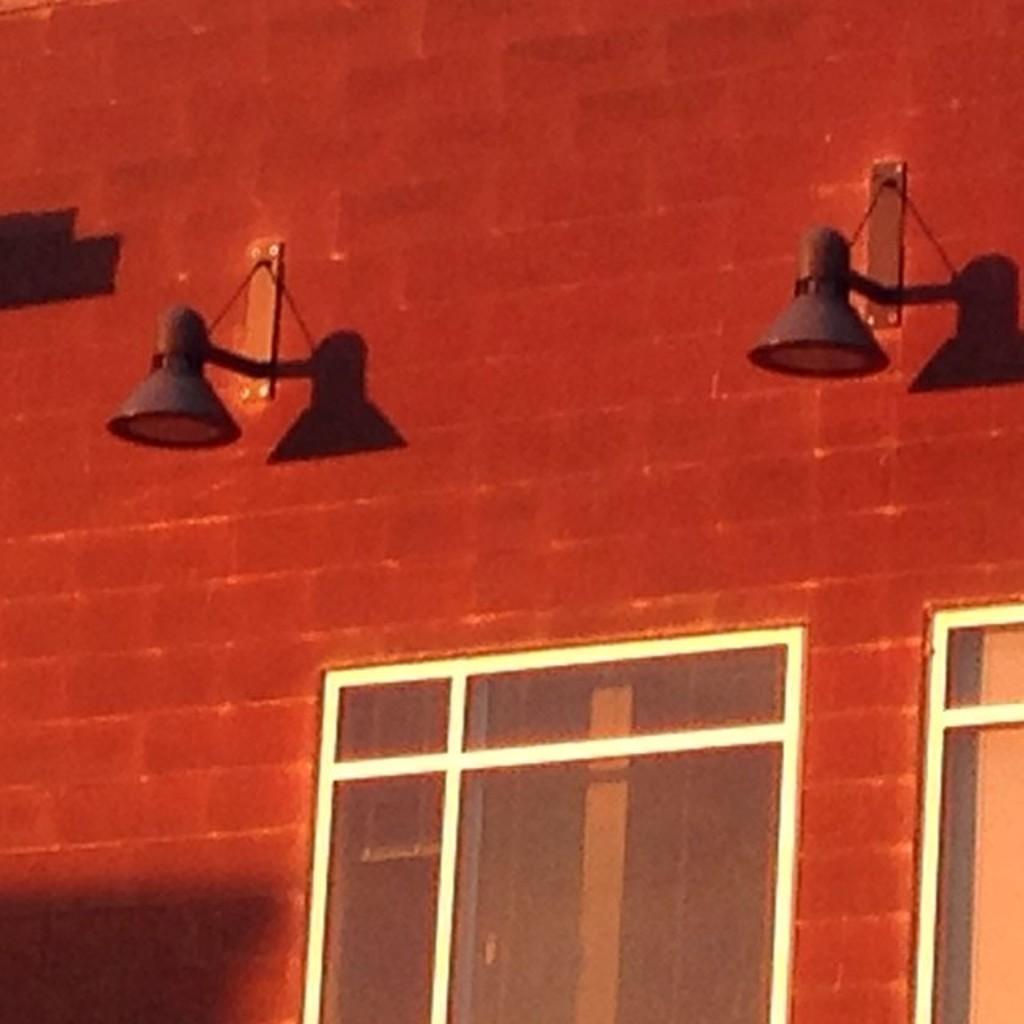How would you summarize this image in a sentence or two? This image consists of a wall in red color along with windows on which we can see the lights. 